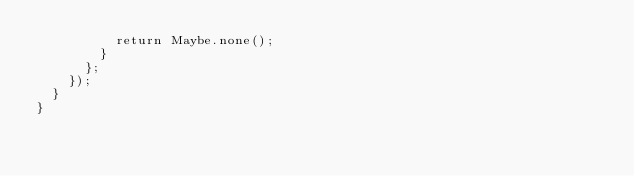Convert code to text. <code><loc_0><loc_0><loc_500><loc_500><_TypeScript_>          return Maybe.none();
        }
      };
    });
  }
}
</code> 